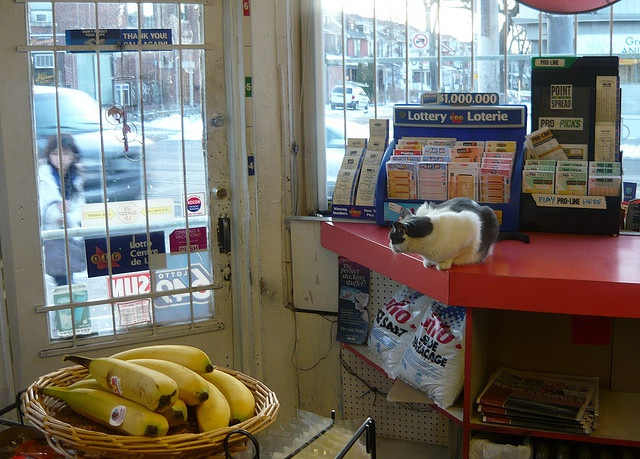Describe the objects in this image and their specific colors. I can see car in gray, white, and lightblue tones, dining table in gray, olive, and black tones, cat in gray, black, and olive tones, banana in gray, olive, and tan tones, and people in gray and lightblue tones in this image. 